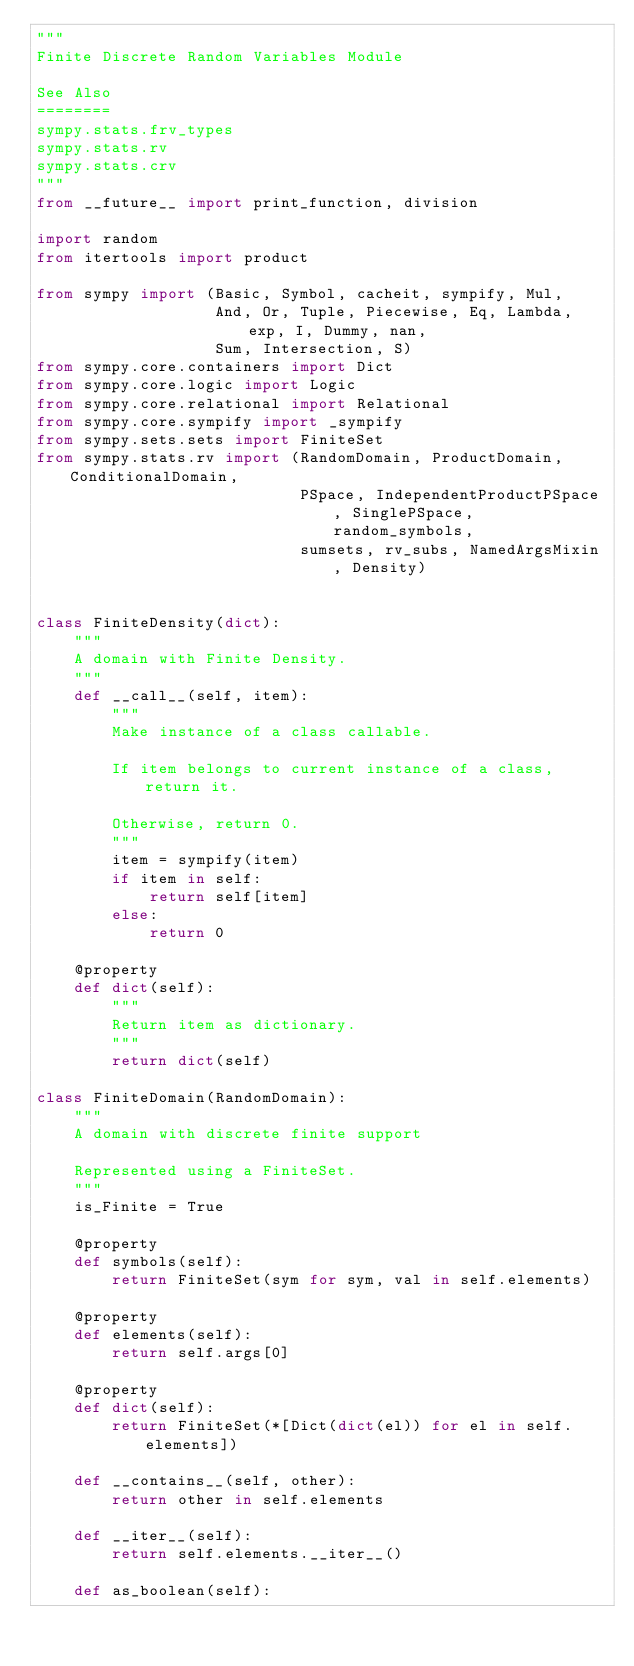Convert code to text. <code><loc_0><loc_0><loc_500><loc_500><_Python_>"""
Finite Discrete Random Variables Module

See Also
========
sympy.stats.frv_types
sympy.stats.rv
sympy.stats.crv
"""
from __future__ import print_function, division

import random
from itertools import product

from sympy import (Basic, Symbol, cacheit, sympify, Mul,
                   And, Or, Tuple, Piecewise, Eq, Lambda, exp, I, Dummy, nan,
                   Sum, Intersection, S)
from sympy.core.containers import Dict
from sympy.core.logic import Logic
from sympy.core.relational import Relational
from sympy.core.sympify import _sympify
from sympy.sets.sets import FiniteSet
from sympy.stats.rv import (RandomDomain, ProductDomain, ConditionalDomain,
                            PSpace, IndependentProductPSpace, SinglePSpace, random_symbols,
                            sumsets, rv_subs, NamedArgsMixin, Density)


class FiniteDensity(dict):
    """
    A domain with Finite Density.
    """
    def __call__(self, item):
        """
        Make instance of a class callable.

        If item belongs to current instance of a class, return it.

        Otherwise, return 0.
        """
        item = sympify(item)
        if item in self:
            return self[item]
        else:
            return 0

    @property
    def dict(self):
        """
        Return item as dictionary.
        """
        return dict(self)

class FiniteDomain(RandomDomain):
    """
    A domain with discrete finite support

    Represented using a FiniteSet.
    """
    is_Finite = True

    @property
    def symbols(self):
        return FiniteSet(sym for sym, val in self.elements)

    @property
    def elements(self):
        return self.args[0]

    @property
    def dict(self):
        return FiniteSet(*[Dict(dict(el)) for el in self.elements])

    def __contains__(self, other):
        return other in self.elements

    def __iter__(self):
        return self.elements.__iter__()

    def as_boolean(self):</code> 